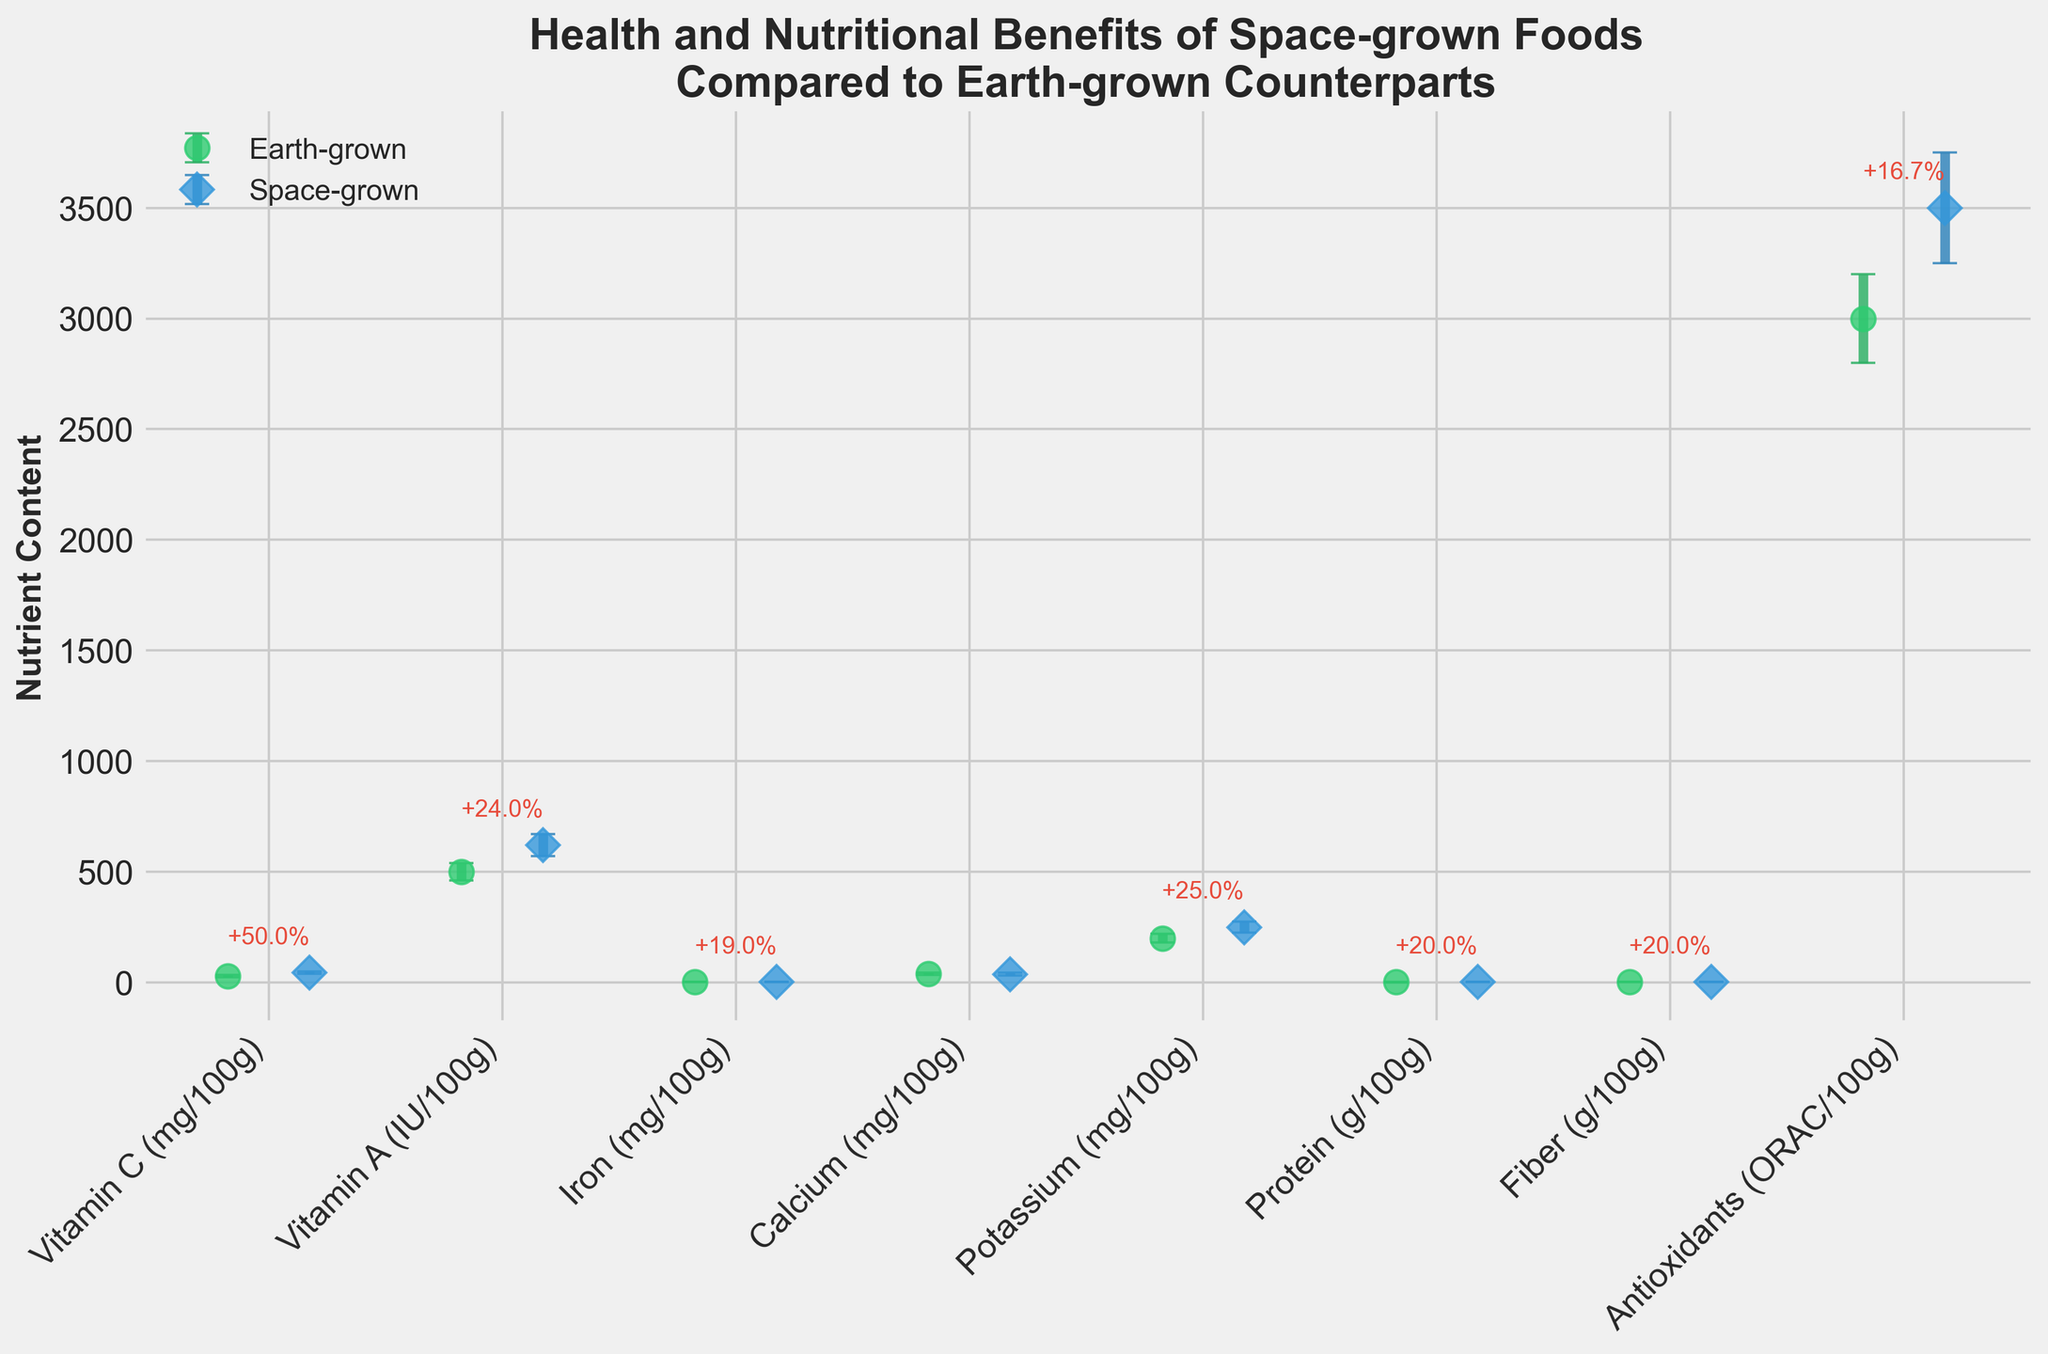Which nutrient shows the highest average nutritional content in space-grown foods? The plot shows the average content for each nutrient. By looking at the space-grown data points (diamonds), we see the nutrient with the highest data point.
Answer: Antioxidants What is the percent increase in Vitamin C content in space-grown foods compared to Earth-grown foods? The figure includes annotations for percentage increases where space-grown means exceed Earth-grown means. The annotation for Vitamin C will tell the specific percentage increase.
Answer: 50.0% Which nutrient shows a lower average content in space-grown foods compared to Earth-grown foods? Examining all the data points, the one where the space-grown mean (diamond) is lower than the Earth-grown mean (circle) indicates a reduction in average content.
Answer: Calcium How does the standard deviation of Iron content compare between Earth-grown and space-grown foods? Locate the Iron content on the figure and compare the lengths of the error bars (vertical lines) for Earth-grown (circle) and space-grown (diamond) foods.
Answer: Higher in space-grown What nutrient has the smallest difference in mean content between Earth-grown and space-grown foods? Calculate or visually compare the differences between each pair of means. The smallest gap between the two markers identifies the nutrient.
Answer: Calcium How does the average Potassium content in space-grown foods compare to Earth-grown foods? Look at the position of the Potassium data points on the plot. Space-grown should be higher if the diamond marker is higher than the circle marker.
Answer: Higher in space-grown foods What does the error bar on each data point represent? Error bars show the standard deviation, which indicates variability around the mean for both Earth-grown and space-grown foods. The plot includes these for each nutrient.
Answer: Standard deviation Which nutrient shows the highest percent increase from Earth-grown to space-grown in the figure? The plot annotates percentage increases. Find the annotation arrow with the highest percentage.
Answer: Vitamin C Which nutrient has the most substantial difference in content between Earth-grown and space-grown foods? Find the nutrient with the largest visual gap between the Earth-grown (circle) and space-grown (diamond) markers.
Answer: Potassium What kind of foods tend to have a greater standard deviation in their nutritional content, space-grown or Earth-grown? By comparing the error bars of all nutrients, determine which type generally has longer error bars.
Answer: Space-grown 